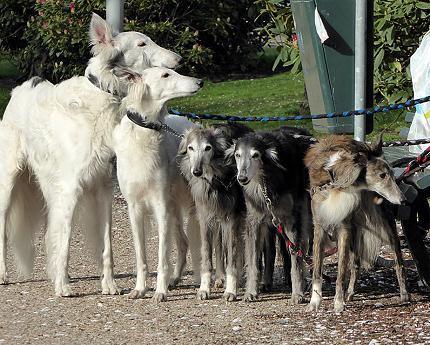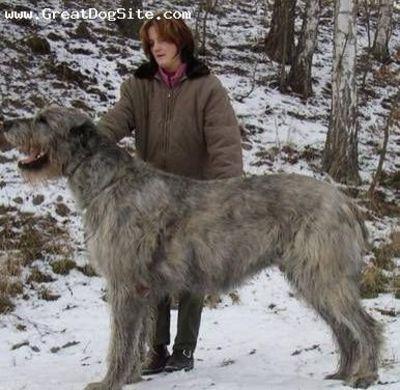The first image is the image on the left, the second image is the image on the right. For the images shown, is this caption "there are two dogs standing in the grass with a wall behind them" true? Answer yes or no. No. 